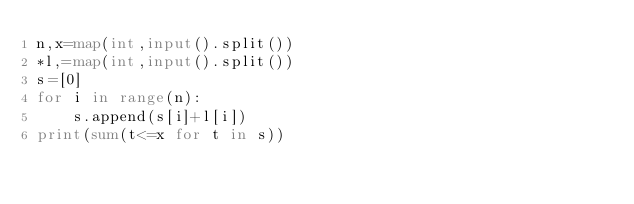Convert code to text. <code><loc_0><loc_0><loc_500><loc_500><_Python_>n,x=map(int,input().split())
*l,=map(int,input().split())
s=[0]
for i in range(n):
    s.append(s[i]+l[i])
print(sum(t<=x for t in s))</code> 